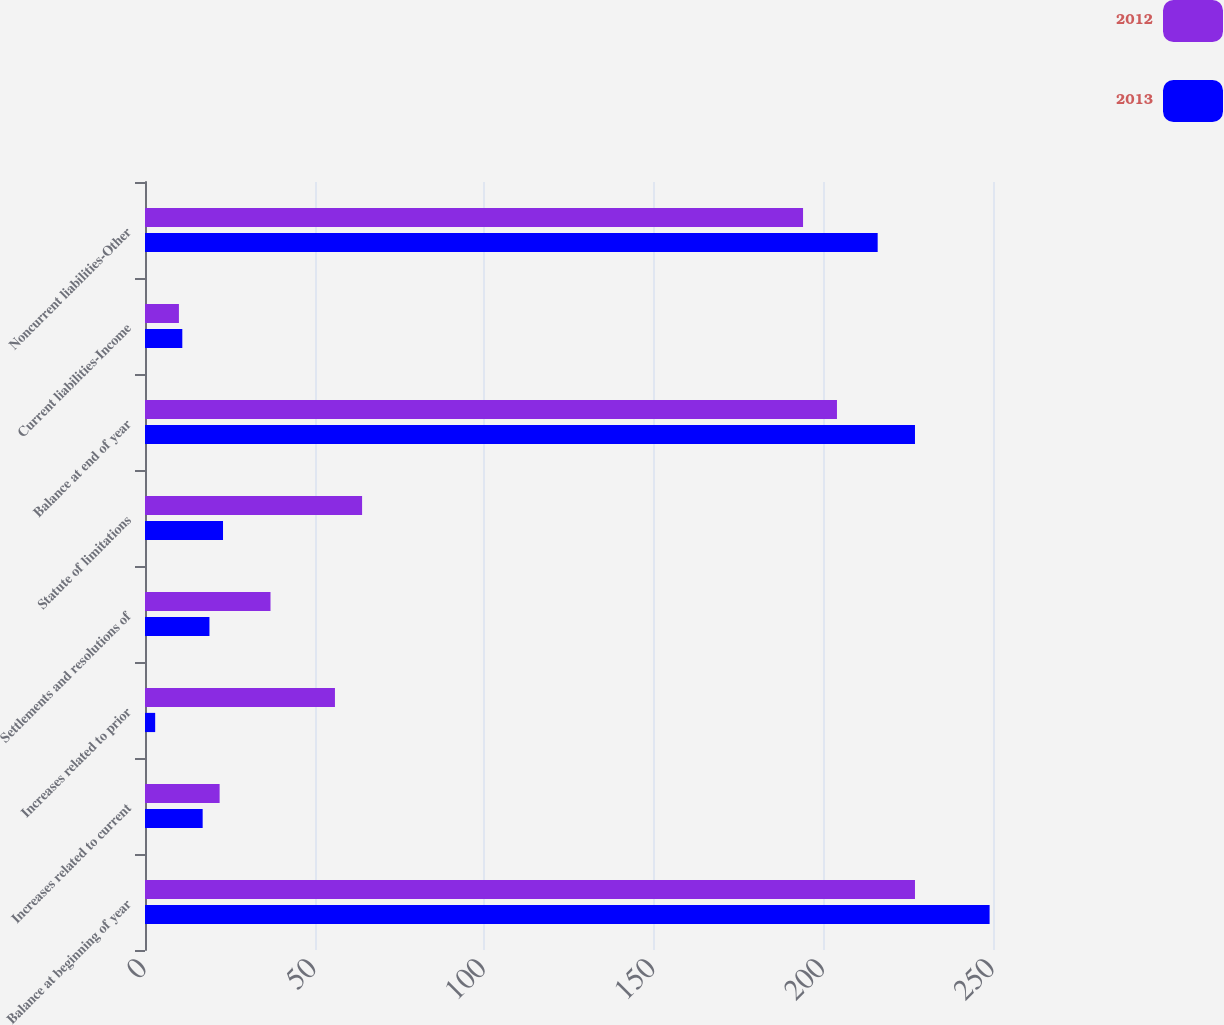Convert chart to OTSL. <chart><loc_0><loc_0><loc_500><loc_500><stacked_bar_chart><ecel><fcel>Balance at beginning of year<fcel>Increases related to current<fcel>Increases related to prior<fcel>Settlements and resolutions of<fcel>Statute of limitations<fcel>Balance at end of year<fcel>Current liabilities-Income<fcel>Noncurrent liabilities-Other<nl><fcel>2012<fcel>227<fcel>22<fcel>56<fcel>37<fcel>64<fcel>204<fcel>10<fcel>194<nl><fcel>2013<fcel>249<fcel>17<fcel>3<fcel>19<fcel>23<fcel>227<fcel>11<fcel>216<nl></chart> 